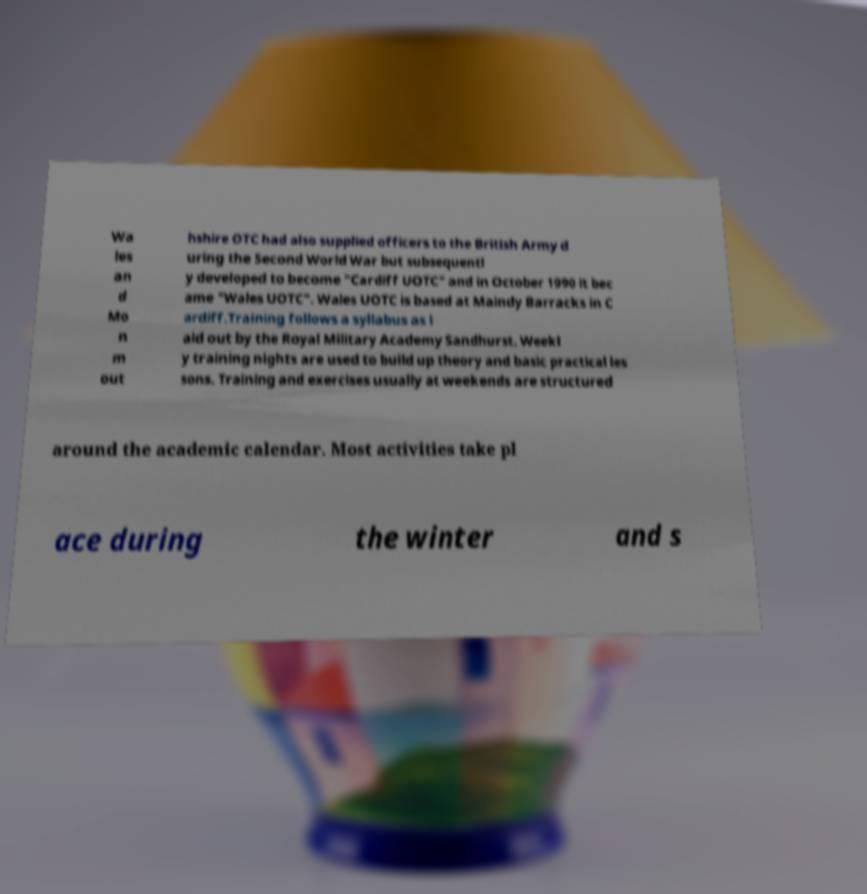What messages or text are displayed in this image? I need them in a readable, typed format. Wa les an d Mo n m out hshire OTC had also supplied officers to the British Army d uring the Second World War but subsequentl y developed to become "Cardiff UOTC" and in October 1990 it bec ame "Wales UOTC". Wales UOTC is based at Maindy Barracks in C ardiff.Training follows a syllabus as l aid out by the Royal Military Academy Sandhurst. Weekl y training nights are used to build up theory and basic practical les sons. Training and exercises usually at weekends are structured around the academic calendar. Most activities take pl ace during the winter and s 